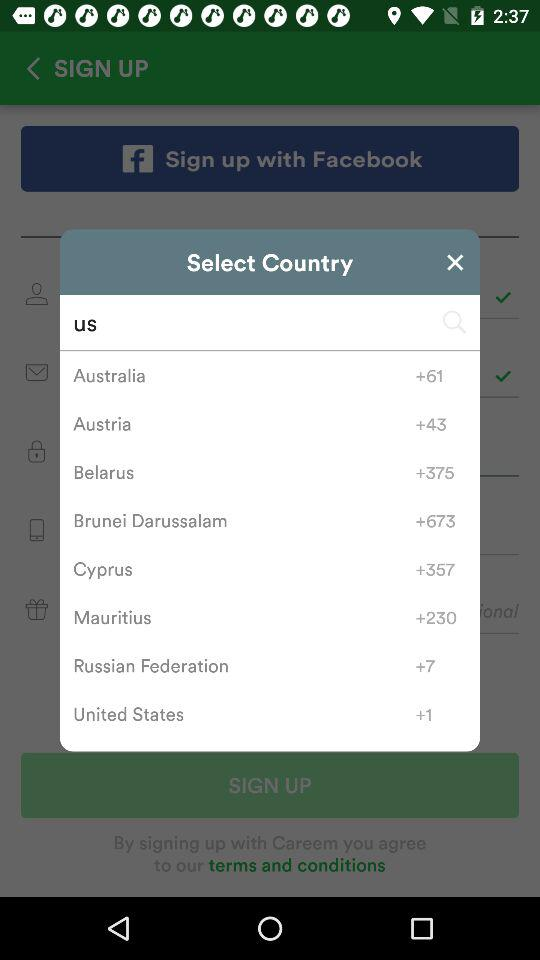What is the country code for the United States? The country code for the United States is +1. 